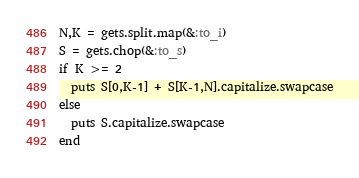<code> <loc_0><loc_0><loc_500><loc_500><_Ruby_>N,K = gets.split.map(&:to_i)
S = gets.chop(&:to_s)
if K >= 2
  puts S[0,K-1] + S[K-1,N].capitalize.swapcase
else
  puts S.capitalize.swapcase
end
</code> 